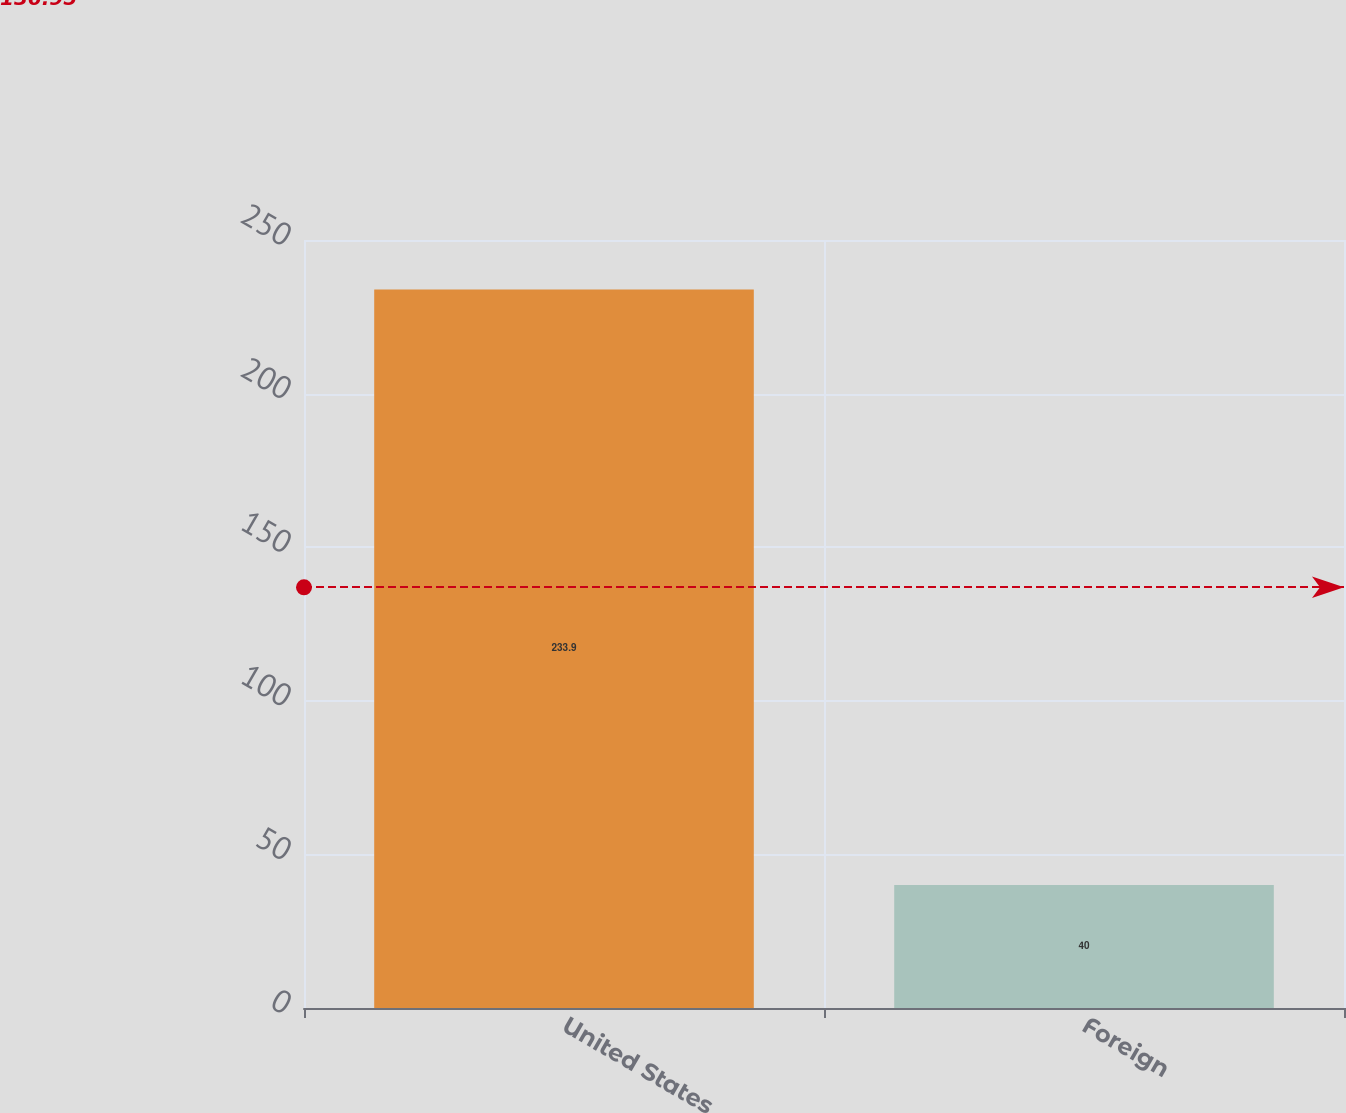Convert chart. <chart><loc_0><loc_0><loc_500><loc_500><bar_chart><fcel>United States<fcel>Foreign<nl><fcel>233.9<fcel>40<nl></chart> 